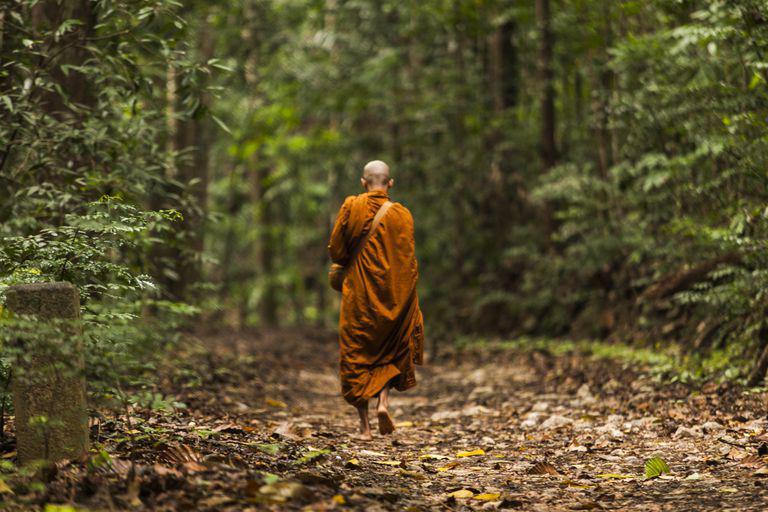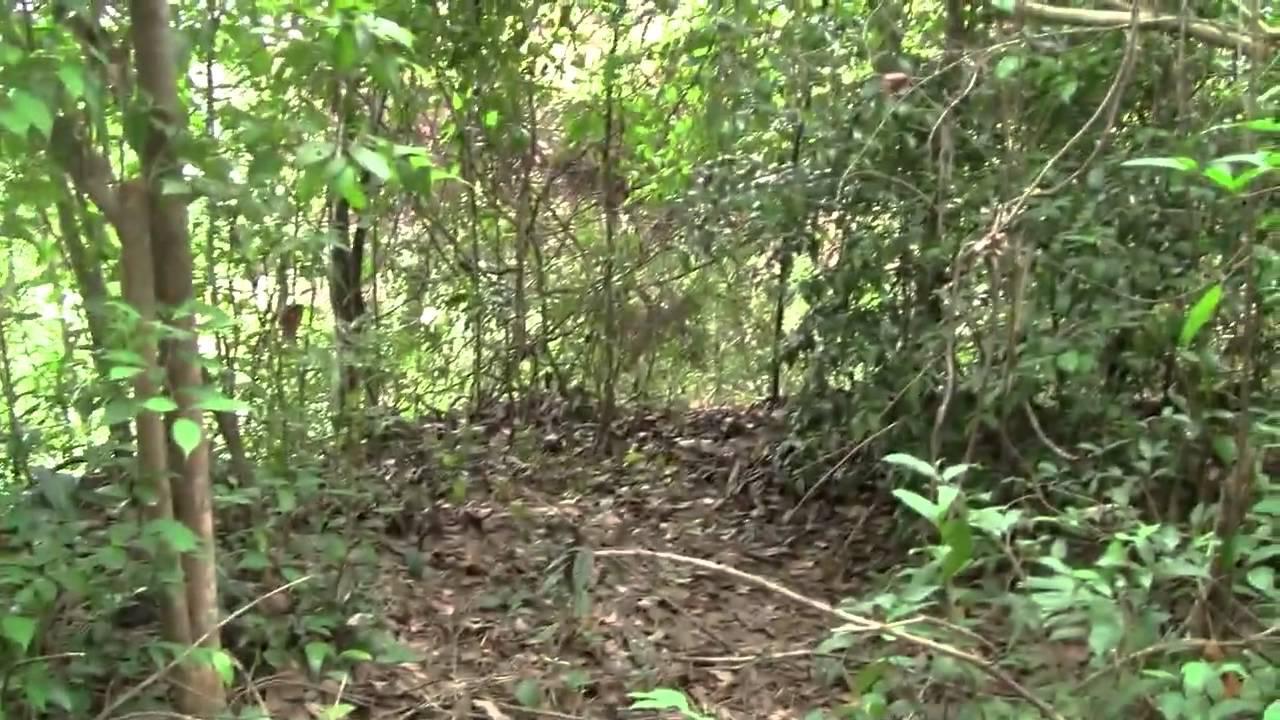The first image is the image on the left, the second image is the image on the right. Analyze the images presented: Is the assertion "In the right image, a figure is sitting in a lotus position on an elevated platform surrounded by foliage and curving vines." valid? Answer yes or no. No. The first image is the image on the left, the second image is the image on the right. Given the left and right images, does the statement "In at least one image there is a single monk walking away into a forest." hold true? Answer yes or no. Yes. 